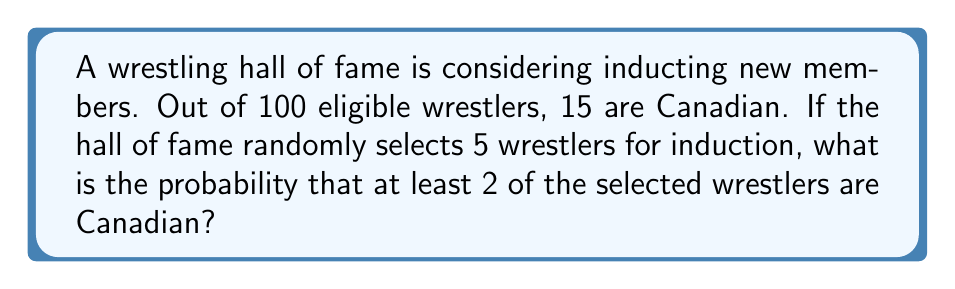Solve this math problem. Let's approach this step-by-step using the complementary probability method:

1) First, we'll calculate the probability of selecting 0 or 1 Canadian wrestler, then subtract this from 1 to get the probability of selecting at least 2.

2) We can use the hypergeometric distribution for this calculation.

3) Probability of selecting 0 Canadian wrestlers:
   $$P(X=0) = \frac{\binom{85}{5}}{\binom{100}{5}}$$

4) Probability of selecting 1 Canadian wrestler:
   $$P(X=1) = \frac{\binom{15}{1}\binom{85}{4}}{\binom{100}{5}}$$

5) Now, let's calculate these values:
   $$P(X=0) = \frac{32,319,760}{75,287,520} \approx 0.4293$$
   $$P(X=1) = \frac{34,427,400}{75,287,520} \approx 0.4572$$

6) The probability of selecting 0 or 1 Canadian wrestler:
   $$P(X \leq 1) = P(X=0) + P(X=1) \approx 0.4293 + 0.4572 = 0.8865$$

7) Therefore, the probability of selecting at least 2 Canadian wrestlers is:
   $$P(X \geq 2) = 1 - P(X \leq 1) \approx 1 - 0.8865 = 0.1135$$
Answer: 0.1135 or approximately 11.35% 